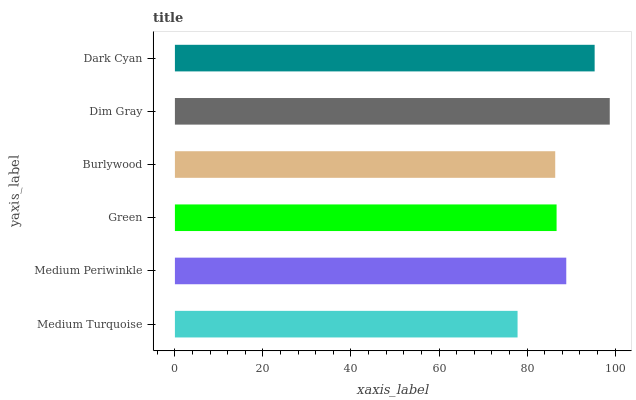Is Medium Turquoise the minimum?
Answer yes or no. Yes. Is Dim Gray the maximum?
Answer yes or no. Yes. Is Medium Periwinkle the minimum?
Answer yes or no. No. Is Medium Periwinkle the maximum?
Answer yes or no. No. Is Medium Periwinkle greater than Medium Turquoise?
Answer yes or no. Yes. Is Medium Turquoise less than Medium Periwinkle?
Answer yes or no. Yes. Is Medium Turquoise greater than Medium Periwinkle?
Answer yes or no. No. Is Medium Periwinkle less than Medium Turquoise?
Answer yes or no. No. Is Medium Periwinkle the high median?
Answer yes or no. Yes. Is Green the low median?
Answer yes or no. Yes. Is Dark Cyan the high median?
Answer yes or no. No. Is Medium Periwinkle the low median?
Answer yes or no. No. 